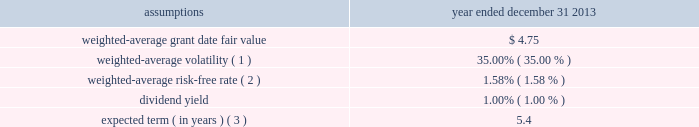Cdw corporation and subsidiaries notes to consolidated financial statements holders of class b common units in connection with the distribution is subject to any vesting provisions previously applicable to the holder 2019s class b common units .
Class b common unit holders received 3798508 shares of restricted stock with respect to class b common units that had not yet vested at the time of the distribution .
For the year ended december 31 , 2013 , 1200544 shares of such restricted stock vested/settled and 5931 shares were forfeited .
As of december 31 , 2013 , 2592033 shares of restricted stock were outstanding .
Stock options in addition , in connection with the ipo , the company issued 1268986 stock options to the class b common unit holders to preserve their fully diluted equity ownership percentage .
These options were issued with a per-share exercise price equal to the ipo price of $ 17.00 and are also subject to the same vesting provisions as the class b common units to which they relate .
The company also granted 19412 stock options under the 2013 ltip during the year ended december 31 , 2013 .
Restricted stock units ( 201crsus 201d ) in connection with the ipo , the company granted 1416543 rsus under the 2013 ltip at a weighted- average grant-date fair value of $ 17.03 per unit .
The rsus cliff-vest at the end of four years .
Valuation information the company attributes the value of equity-based compensation awards to the various periods during which the recipient must perform services in order to vest in the award using the straight-line method .
Post-ipo equity awards the company has elected to use the black-scholes option pricing model to estimate the fair value of stock options granted .
The black-scholes option pricing model incorporates various assumptions including volatility , expected term , risk-free interest rates and dividend yields .
The assumptions used to value the stock options granted during the year ended december 31 , 2013 are presented below .
Year ended december 31 , assumptions 2013 .
Expected term ( in years ) ( 3 ) .
5.4 ( 1 ) based upon an assessment of the two-year , five-year and implied volatility for the company 2019s selected peer group , adjusted for the company 2019s leverage .
( 2 ) based on a composite u.s .
Treasury rate .
( 3 ) the expected term is calculated using the simplified method .
The simplified method defines the expected term as the average of the option 2019s contractual term and the option 2019s weighted-average vesting period .
The company utilizes this method as it has limited historical stock option data that is sufficient to derive a reasonable estimate of the expected stock option term. .
For the restricted stock units ( 201crsus 201d ) granted in connection with the ipo , what would the total deemed proceeds be to the company assuming the rsus were vested at the average price per unit? 
Computations: (17.03 * 1416543)
Answer: 24123727.29. 